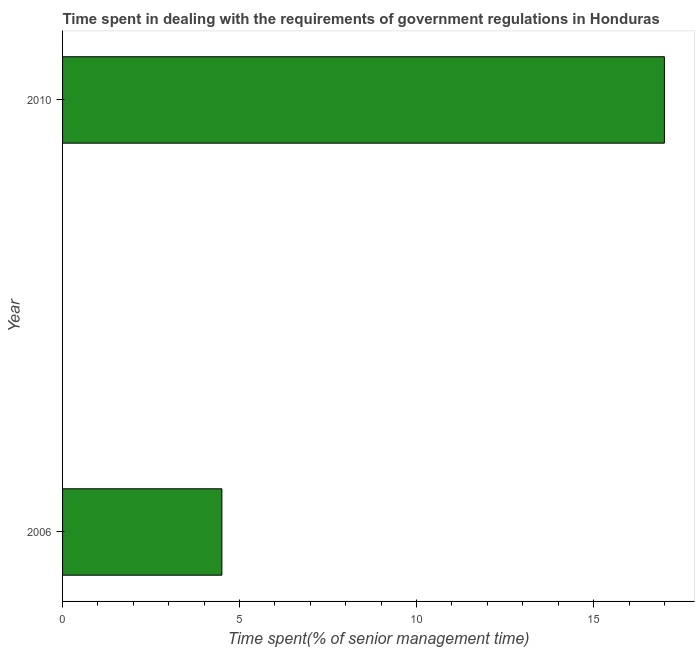Does the graph contain grids?
Keep it short and to the point. No. What is the title of the graph?
Provide a succinct answer. Time spent in dealing with the requirements of government regulations in Honduras. What is the label or title of the X-axis?
Keep it short and to the point. Time spent(% of senior management time). What is the time spent in dealing with government regulations in 2006?
Your answer should be compact. 4.5. Across all years, what is the maximum time spent in dealing with government regulations?
Offer a very short reply. 17. Across all years, what is the minimum time spent in dealing with government regulations?
Offer a very short reply. 4.5. In which year was the time spent in dealing with government regulations maximum?
Make the answer very short. 2010. What is the sum of the time spent in dealing with government regulations?
Provide a succinct answer. 21.5. What is the difference between the time spent in dealing with government regulations in 2006 and 2010?
Provide a short and direct response. -12.5. What is the average time spent in dealing with government regulations per year?
Ensure brevity in your answer.  10.75. What is the median time spent in dealing with government regulations?
Your answer should be compact. 10.75. In how many years, is the time spent in dealing with government regulations greater than 11 %?
Offer a very short reply. 1. Do a majority of the years between 2006 and 2010 (inclusive) have time spent in dealing with government regulations greater than 4 %?
Make the answer very short. Yes. What is the ratio of the time spent in dealing with government regulations in 2006 to that in 2010?
Ensure brevity in your answer.  0.27. How many bars are there?
Provide a succinct answer. 2. Are all the bars in the graph horizontal?
Your response must be concise. Yes. How many years are there in the graph?
Provide a succinct answer. 2. Are the values on the major ticks of X-axis written in scientific E-notation?
Your response must be concise. No. What is the ratio of the Time spent(% of senior management time) in 2006 to that in 2010?
Provide a succinct answer. 0.27. 